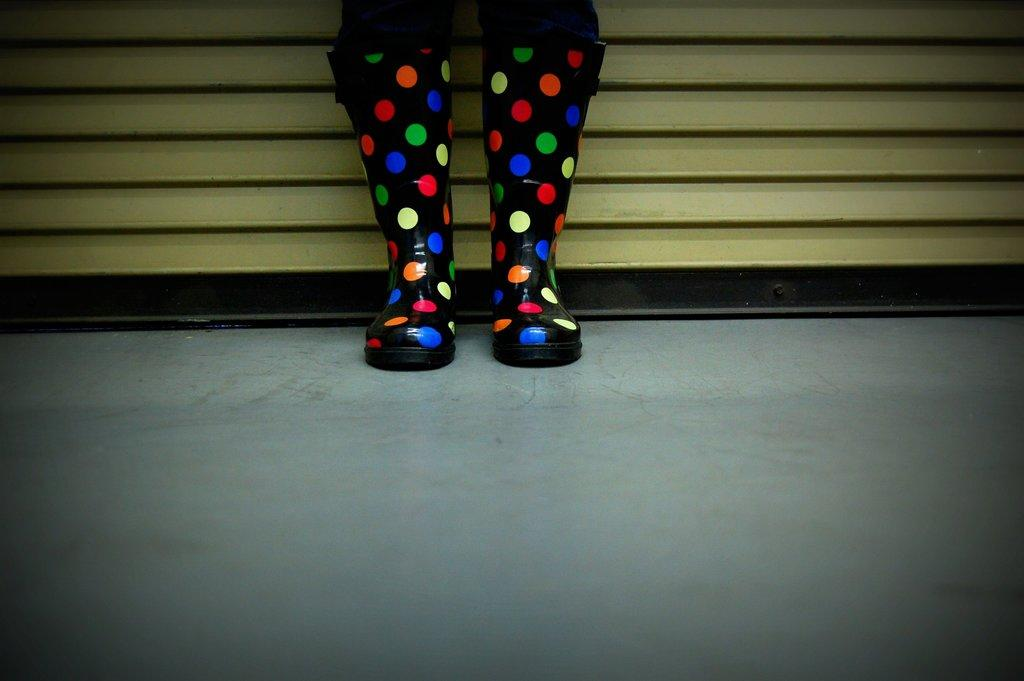What type of footwear is visible on the surface in the image? There are colorful boots on the surface in the image. What can be seen in the background of the image? There is a shutter in the background of the image. What type of net is being used to catch the sun in the image? There is no net or sun present in the image. What type of camera is being used to capture the image? The facts provided do not mention a camera, so it cannot be determined from the image. 